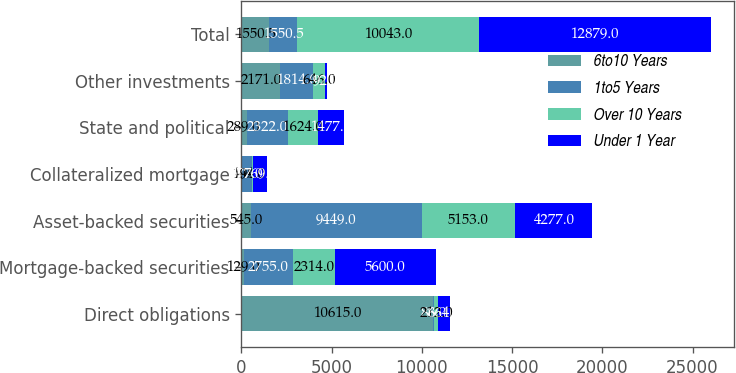Convert chart to OTSL. <chart><loc_0><loc_0><loc_500><loc_500><stacked_bar_chart><ecel><fcel>Direct obligations<fcel>Mortgage-backed securities<fcel>Asset-backed securities<fcel>Collateralized mortgage<fcel>State and political<fcel>Other investments<fcel>Total<nl><fcel>6to10 Years<fcel>10615<fcel>129<fcel>545<fcel>1<fcel>289<fcel>2171<fcel>1550.5<nl><fcel>1to5 Years<fcel>88<fcel>2755<fcel>9449<fcel>577<fcel>2322<fcel>1814<fcel>1550.5<nl><fcel>Over 10 Years<fcel>212<fcel>2314<fcel>5153<fcel>94<fcel>1624<fcel>646<fcel>10043<nl><fcel>Under 1 Year<fcel>664<fcel>5600<fcel>4277<fcel>769<fcel>1477<fcel>92<fcel>12879<nl></chart> 